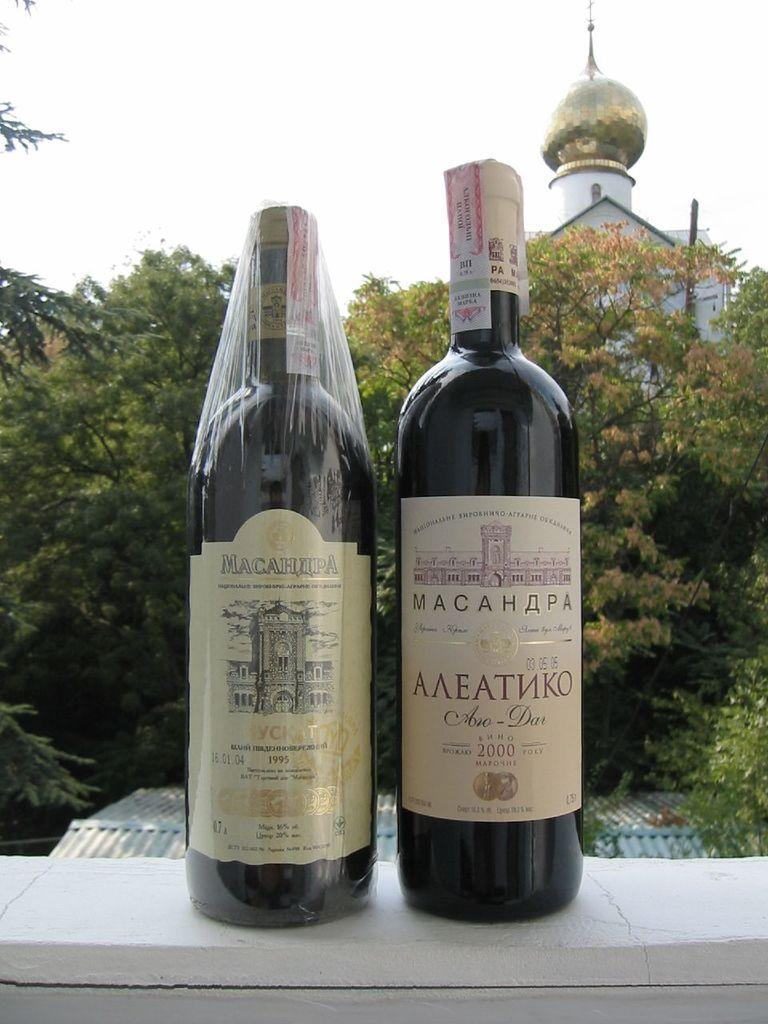<image>
Summarize the visual content of the image. A bottle of wine from 1995 sits near a bottle of wine from 2000. 